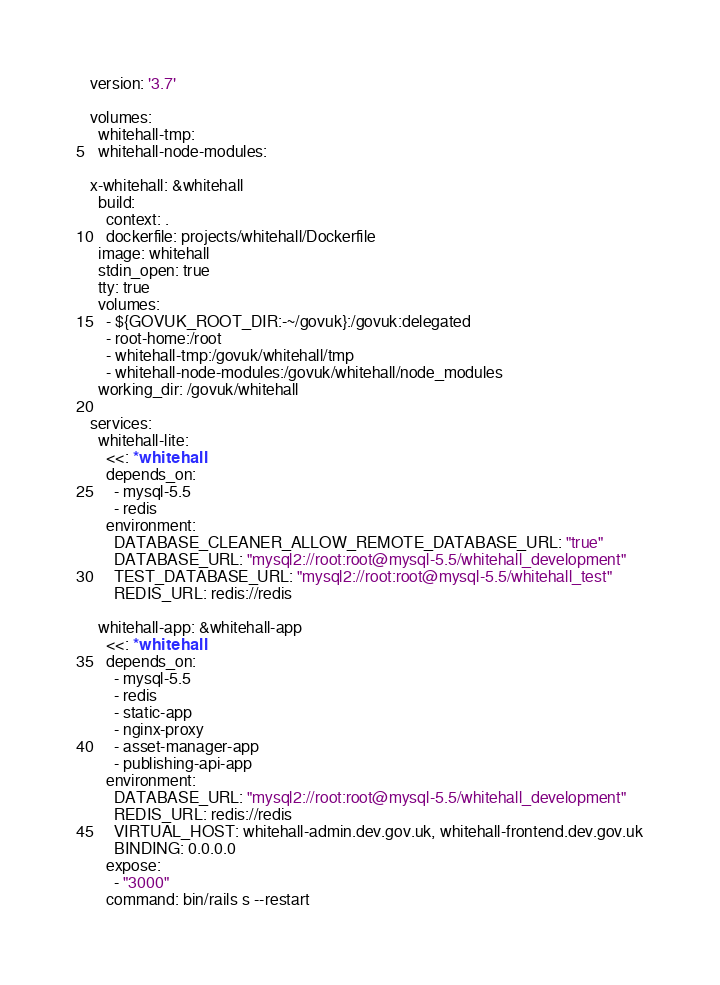<code> <loc_0><loc_0><loc_500><loc_500><_YAML_>version: '3.7'

volumes:
  whitehall-tmp:
  whitehall-node-modules:

x-whitehall: &whitehall
  build:
    context: .
    dockerfile: projects/whitehall/Dockerfile
  image: whitehall
  stdin_open: true
  tty: true
  volumes:
    - ${GOVUK_ROOT_DIR:-~/govuk}:/govuk:delegated
    - root-home:/root
    - whitehall-tmp:/govuk/whitehall/tmp
    - whitehall-node-modules:/govuk/whitehall/node_modules
  working_dir: /govuk/whitehall

services:
  whitehall-lite:
    <<: *whitehall
    depends_on:
      - mysql-5.5
      - redis
    environment:
      DATABASE_CLEANER_ALLOW_REMOTE_DATABASE_URL: "true"
      DATABASE_URL: "mysql2://root:root@mysql-5.5/whitehall_development"
      TEST_DATABASE_URL: "mysql2://root:root@mysql-5.5/whitehall_test"
      REDIS_URL: redis://redis

  whitehall-app: &whitehall-app
    <<: *whitehall
    depends_on:
      - mysql-5.5
      - redis
      - static-app
      - nginx-proxy
      - asset-manager-app
      - publishing-api-app
    environment:
      DATABASE_URL: "mysql2://root:root@mysql-5.5/whitehall_development"
      REDIS_URL: redis://redis
      VIRTUAL_HOST: whitehall-admin.dev.gov.uk, whitehall-frontend.dev.gov.uk
      BINDING: 0.0.0.0
    expose:
      - "3000"
    command: bin/rails s --restart
</code> 